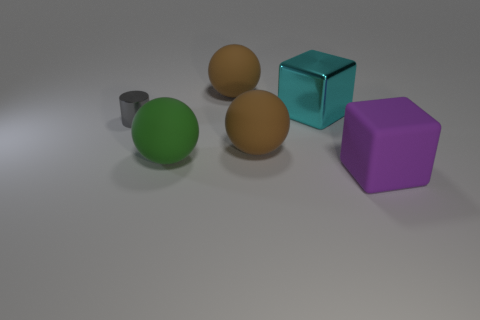Add 1 big cyan shiny things. How many objects exist? 7 Subtract all cylinders. How many objects are left? 5 Subtract all cylinders. Subtract all metallic cubes. How many objects are left? 4 Add 5 brown things. How many brown things are left? 7 Add 4 green things. How many green things exist? 5 Subtract 0 blue cubes. How many objects are left? 6 